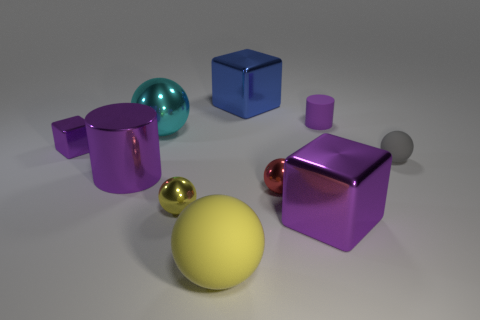Subtract 1 balls. How many balls are left? 4 Subtract all yellow rubber spheres. How many spheres are left? 4 Subtract all gray spheres. How many spheres are left? 4 Subtract all blue spheres. Subtract all blue cylinders. How many spheres are left? 5 Subtract all cylinders. How many objects are left? 8 Subtract 0 yellow blocks. How many objects are left? 10 Subtract all large cylinders. Subtract all yellow objects. How many objects are left? 7 Add 7 cyan metallic spheres. How many cyan metallic spheres are left? 8 Add 7 rubber objects. How many rubber objects exist? 10 